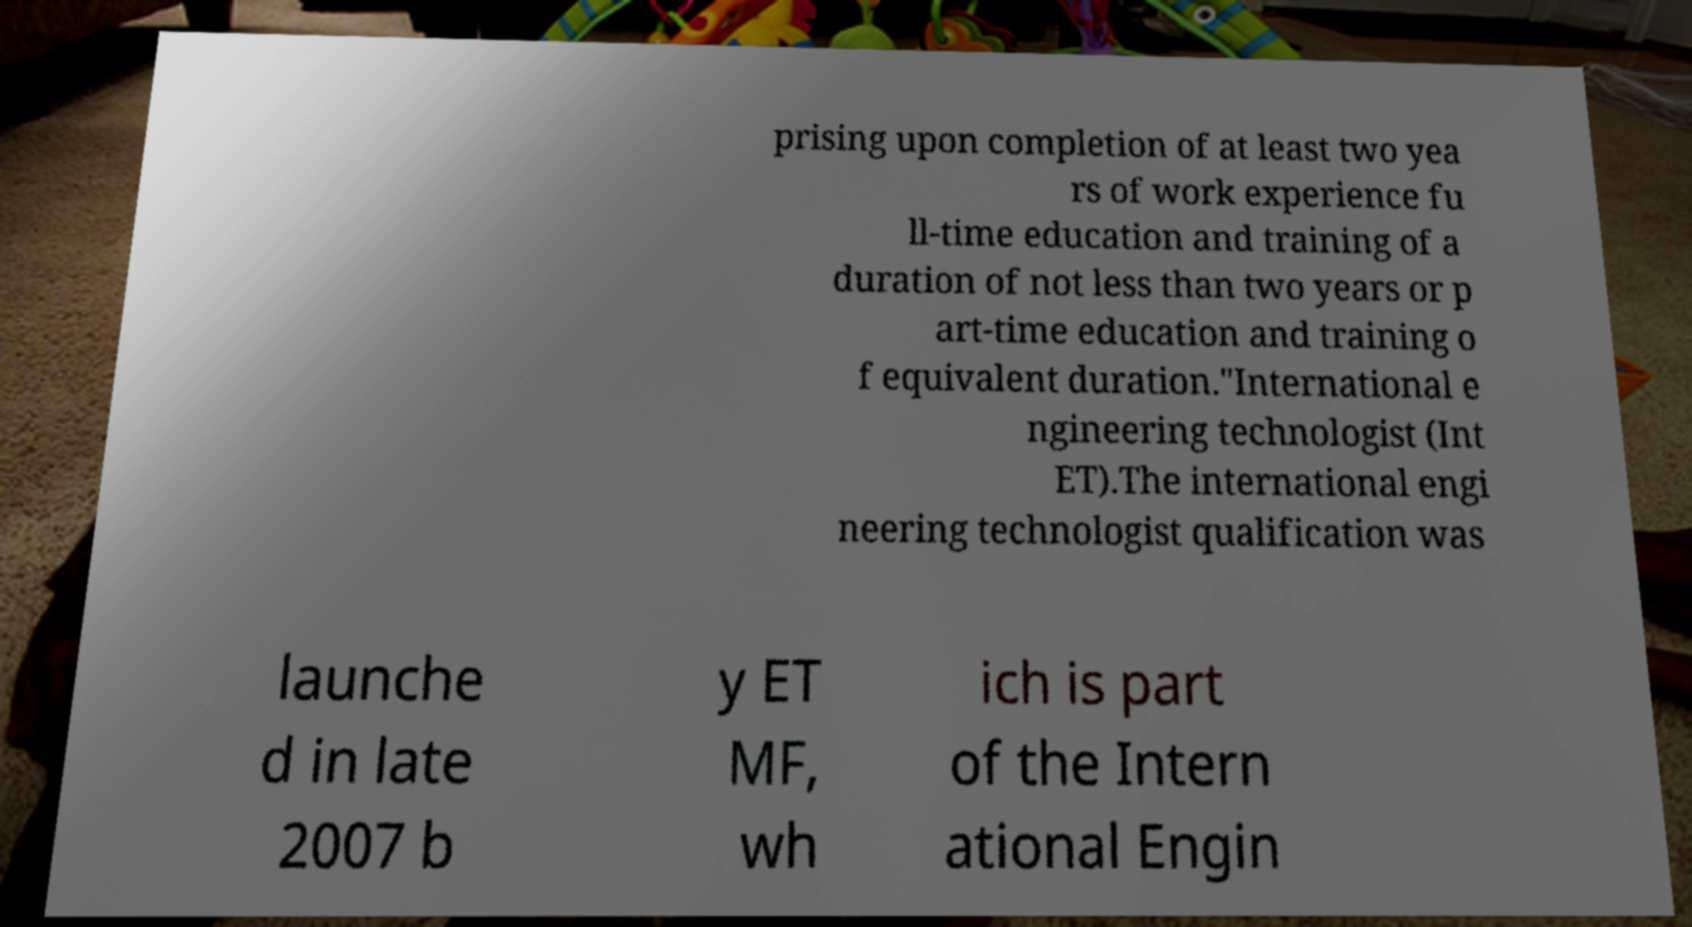Could you extract and type out the text from this image? prising upon completion of at least two yea rs of work experience fu ll-time education and training of a duration of not less than two years or p art-time education and training o f equivalent duration."International e ngineering technologist (Int ET).The international engi neering technologist qualification was launche d in late 2007 b y ET MF, wh ich is part of the Intern ational Engin 